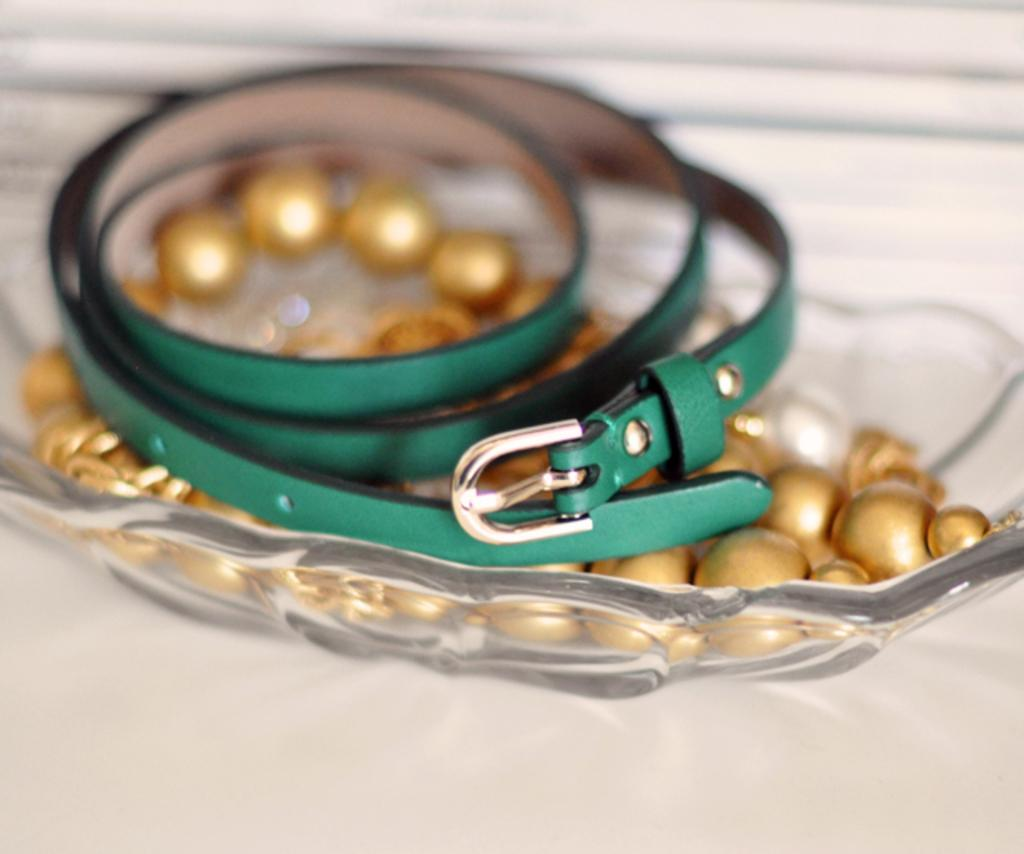What is located in the center of the image? There is a plate in the center of the image. What is on the plate? There are pearls and a belt on the plate. What type of furniture is visible at the bottom of the image? There appears to be a table at the bottom of the image. What type of cup can be seen filled with lead in the image? There is no cup or lead present in the image. 